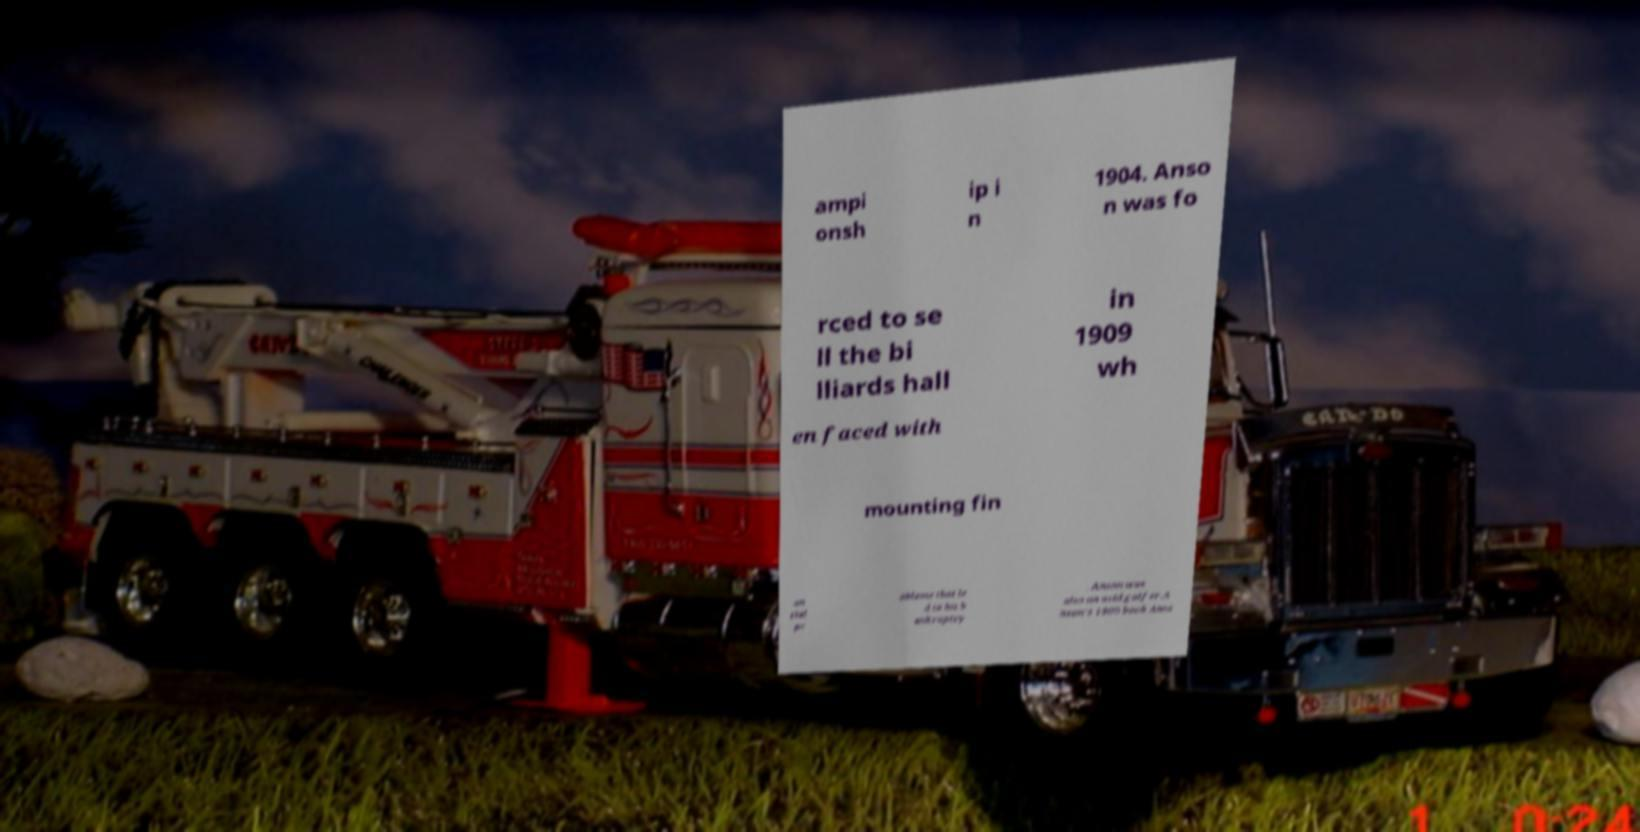Please read and relay the text visible in this image. What does it say? ampi onsh ip i n 1904. Anso n was fo rced to se ll the bi lliards hall in 1909 wh en faced with mounting fin an cial pr oblems that le d to his b ankruptcy . Anson was also an avid golfer.A nson's 1900 book Anso 